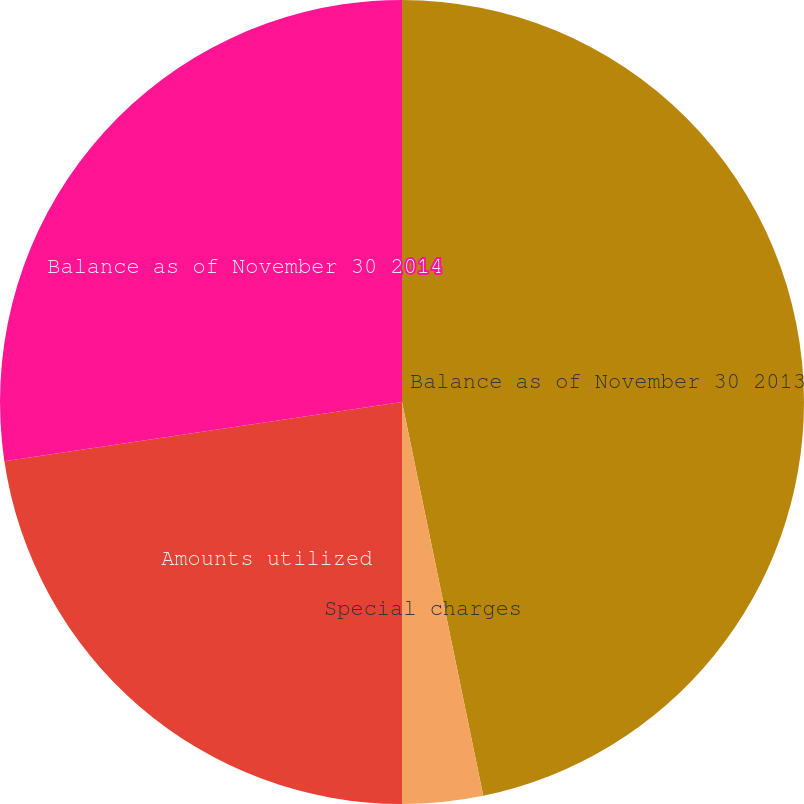<chart> <loc_0><loc_0><loc_500><loc_500><pie_chart><fcel>Balance as of November 30 2013<fcel>Special charges<fcel>Amounts utilized<fcel>Balance as of November 30 2014<nl><fcel>46.76%<fcel>3.24%<fcel>22.65%<fcel>27.35%<nl></chart> 